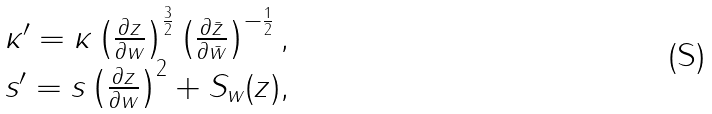Convert formula to latex. <formula><loc_0><loc_0><loc_500><loc_500>\begin{array} { l l } \kappa ^ { \prime } = \kappa \left ( \frac { \partial z } { \partial w } \right ) ^ { \frac { 3 } { 2 } } \left ( \frac { \partial \bar { z } } { \partial \bar { w } } \right ) ^ { - \frac { 1 } { 2 } } , \\ s ^ { \prime } = s \left ( \frac { \partial z } { \partial w } \right ) ^ { 2 } + S _ { w } ( z ) , \end{array}</formula> 